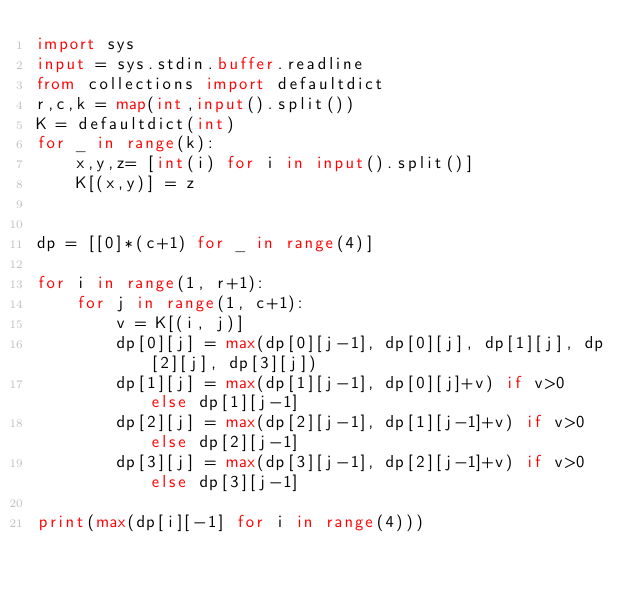<code> <loc_0><loc_0><loc_500><loc_500><_Python_>import sys
input = sys.stdin.buffer.readline
from collections import defaultdict
r,c,k = map(int,input().split())
K = defaultdict(int)
for _ in range(k):
    x,y,z= [int(i) for i in input().split()]
    K[(x,y)] = z


dp = [[0]*(c+1) for _ in range(4)]
 
for i in range(1, r+1):
    for j in range(1, c+1):
        v = K[(i, j)]
        dp[0][j] = max(dp[0][j-1], dp[0][j], dp[1][j], dp[2][j], dp[3][j])
        dp[1][j] = max(dp[1][j-1], dp[0][j]+v) if v>0 else dp[1][j-1]
        dp[2][j] = max(dp[2][j-1], dp[1][j-1]+v) if v>0 else dp[2][j-1]
        dp[3][j] = max(dp[3][j-1], dp[2][j-1]+v) if v>0 else dp[3][j-1]
        
print(max(dp[i][-1] for i in range(4)))</code> 